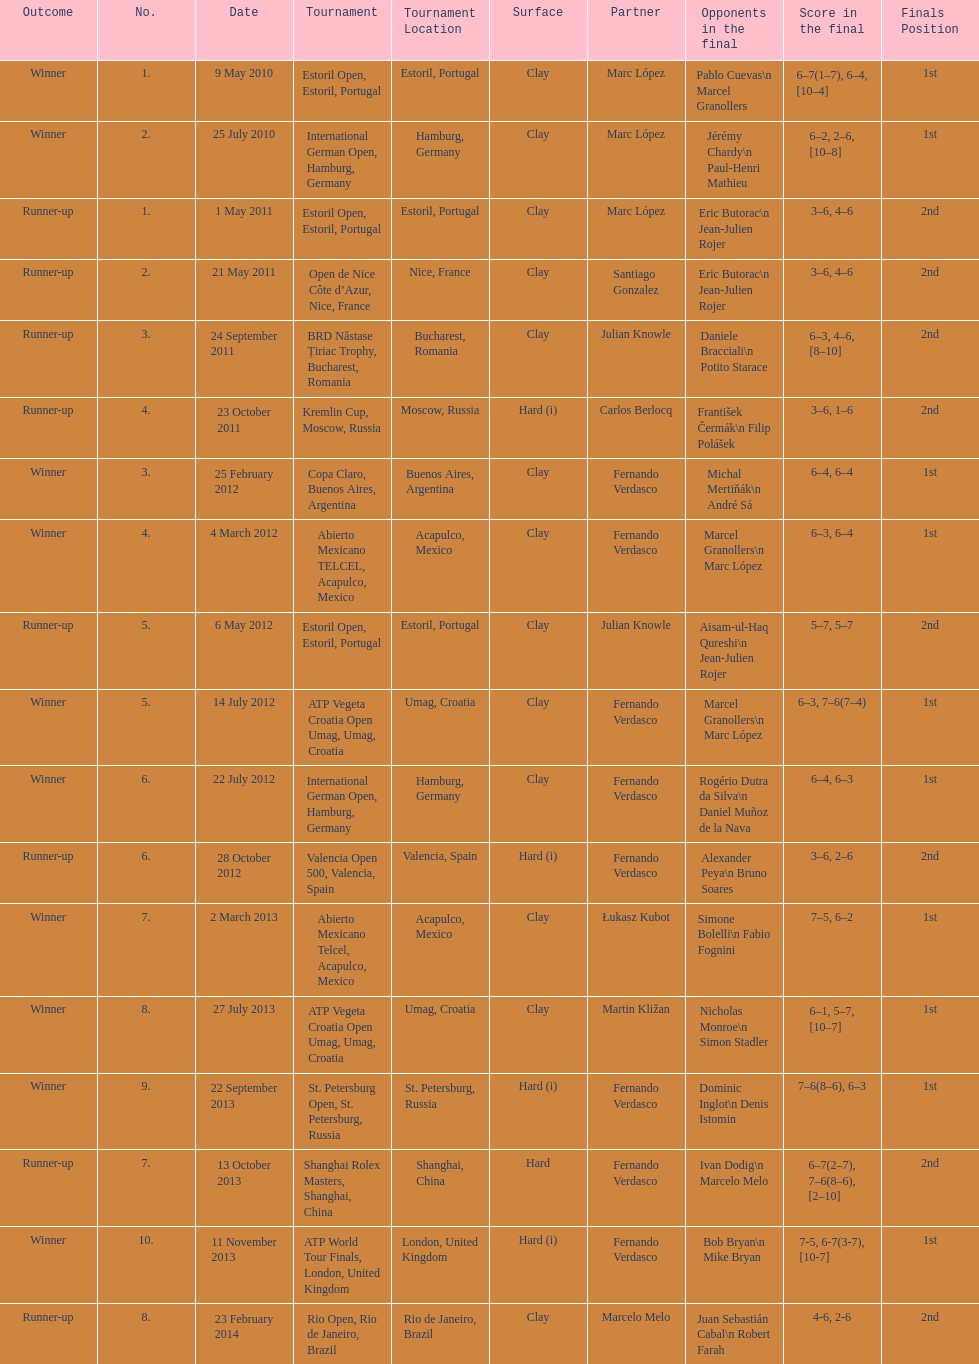Who won both the st.petersburg open and the atp world tour finals? Fernando Verdasco. 